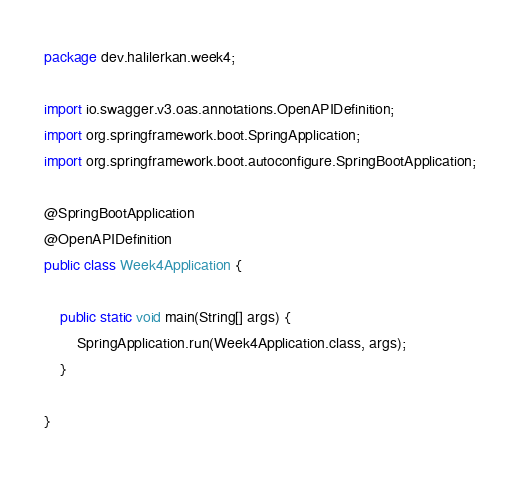Convert code to text. <code><loc_0><loc_0><loc_500><loc_500><_Java_>package dev.halilerkan.week4;

import io.swagger.v3.oas.annotations.OpenAPIDefinition;
import org.springframework.boot.SpringApplication;
import org.springframework.boot.autoconfigure.SpringBootApplication;

@SpringBootApplication
@OpenAPIDefinition
public class Week4Application {

    public static void main(String[] args) {
        SpringApplication.run(Week4Application.class, args);
    }

}
</code> 